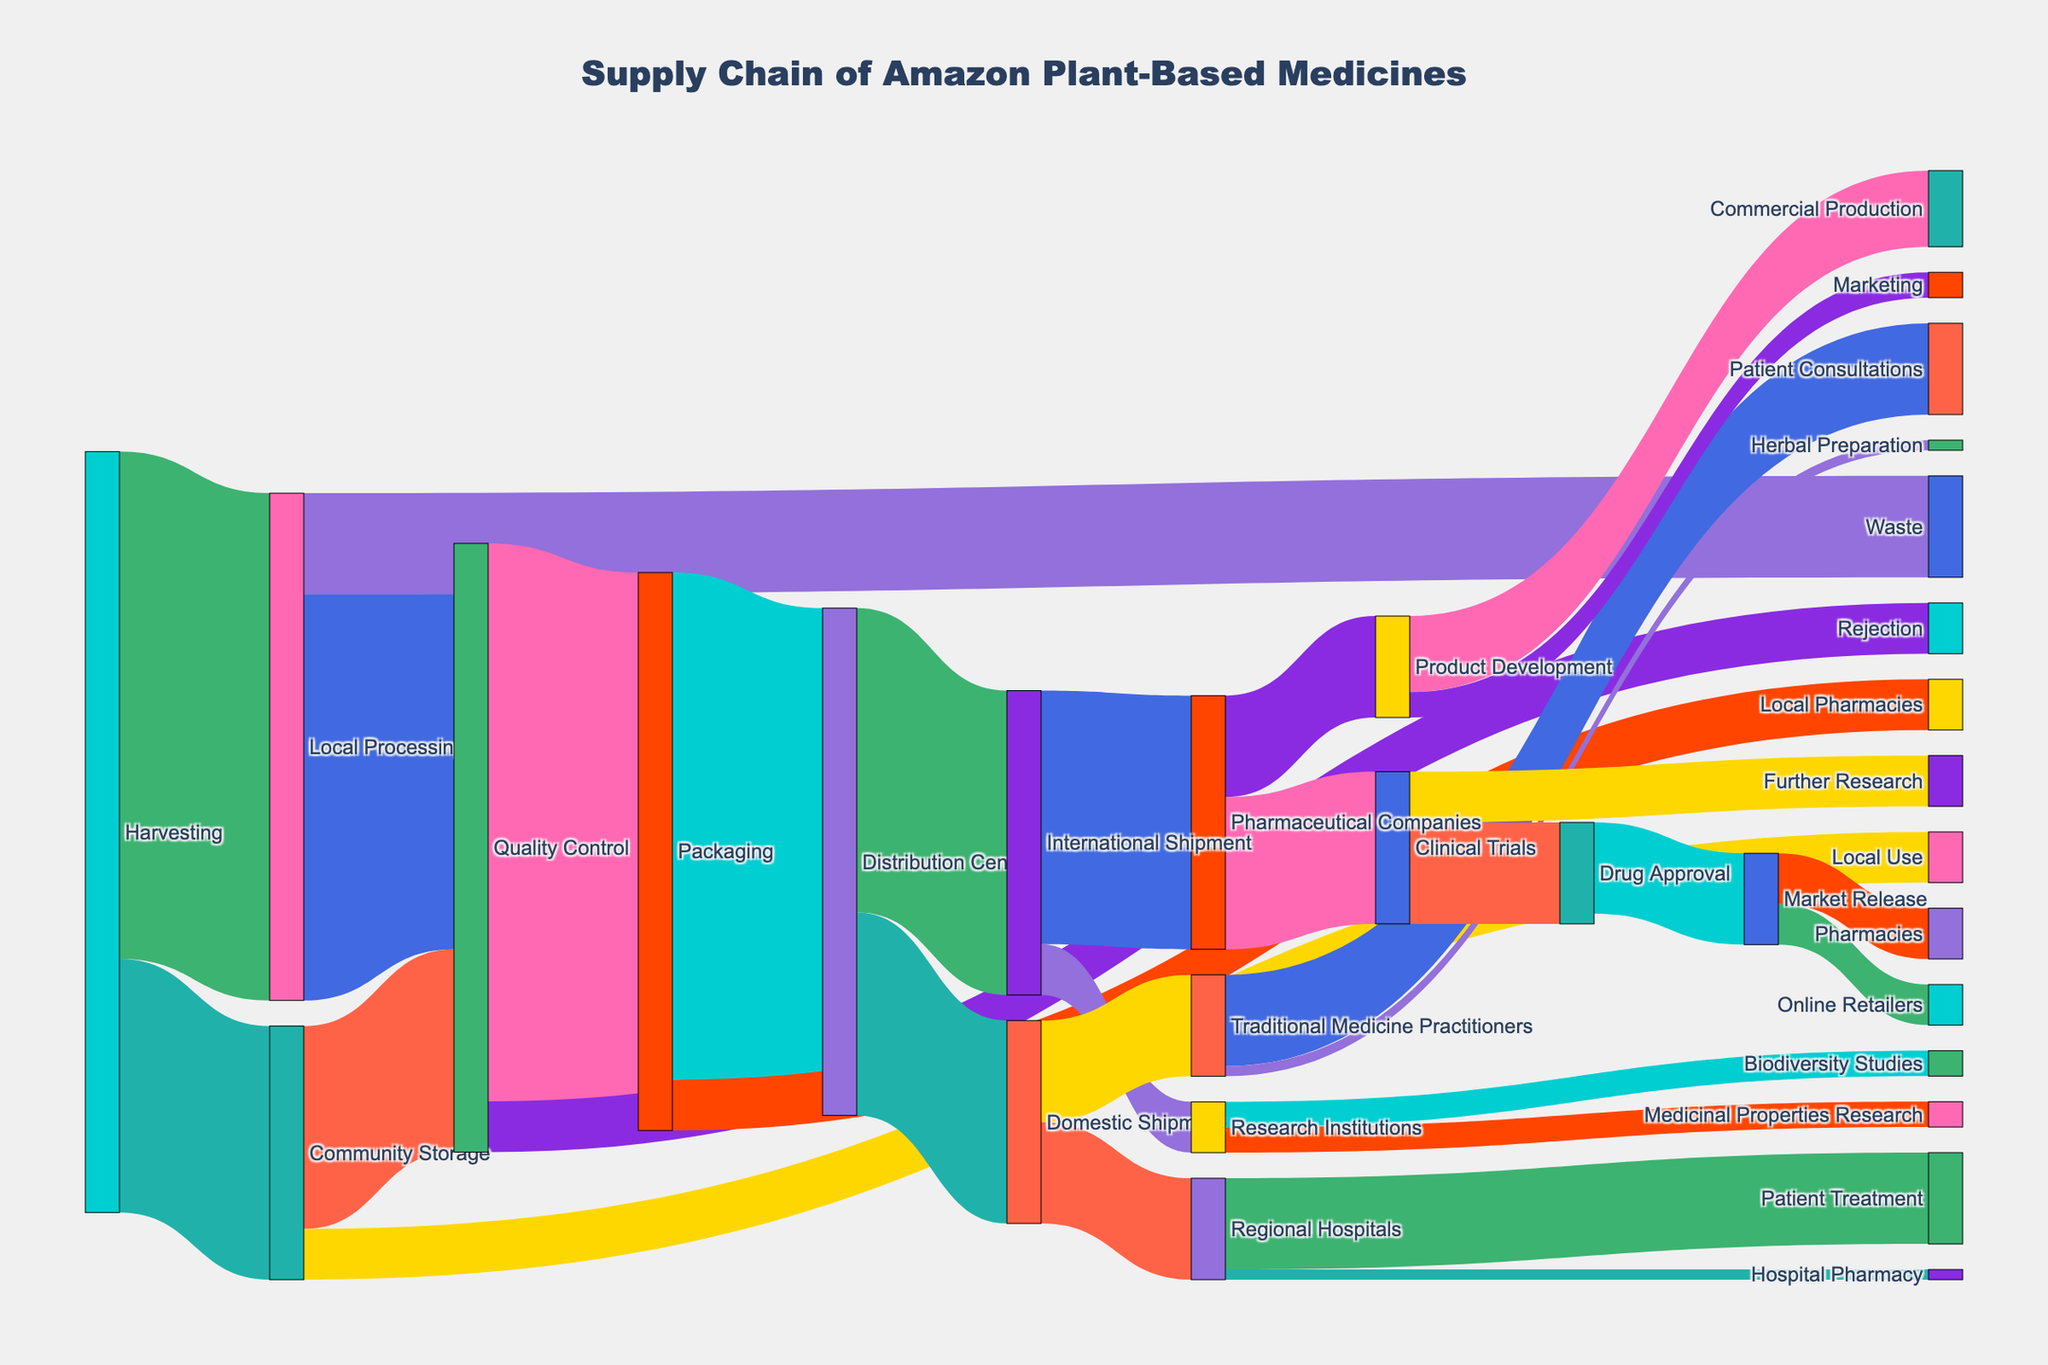What is the total amount of plants harvested? To find the total amount harvested, sum all values connected to "Harvesting": 1000 (to Local Processing) + 500 (to Community Storage) = 1500.
Answer: 1500 Which process receives the highest amount from Quality Control? Identify which target from "Quality Control" has the highest value: Packaging (1100), Rejection (100). 1100 is the largest.
Answer: Packaging What is the final quantity that reaches Traditional Medicine Practitioners? From "Domestic Shipment", Traditional Medicine Practitioners receive 200.
Answer: 200 How much of the plants initially stored in Community Storage ends up in Local Use? Look for the value directly connected from “Community Storage” to “Local Use”, which is 100.
Answer: 100 What's the difference between the amount of plants rejected during Quality Control and the amount redirected to Packaging? Values from "Quality Control" are: Packaging (1100), Rejection (100). Difference: 1100 - 100 = 1000.
Answer: 1000 Which stakeholder receives the highest number of plants for medicinal research? Sum the values directed towards Research Institutions: Medicinal Properties Research (50), Biodiversity Studies (50). Highest value is 50 and both receive an equal amount.
Answer: Medicinal Properties Research and Biodiversity Studies How many steps include processing before reaching Research Institutions? Trace the steps leading to Research Institutions: Harvesting → Community Storage → Quality Control → Packaging → Distribution Center → International Shipment → Research Institutions. This involves 6 steps before reaching the final destination.
Answer: 6 What is the total quantity assessed by Quality Control? Sum all values connected to "Quality Control": Rejection (100) + Packaging (1100) = 1200.
Answer: 1200 Compare the amount of plants going to International Shipment vs. Domestic Shipment from the Distribution Center. Which is greater? Values from "Distribution Center" are: International Shipment (600), Domestic Shipment (400). International Shipment is greater.
Answer: International Shipment 